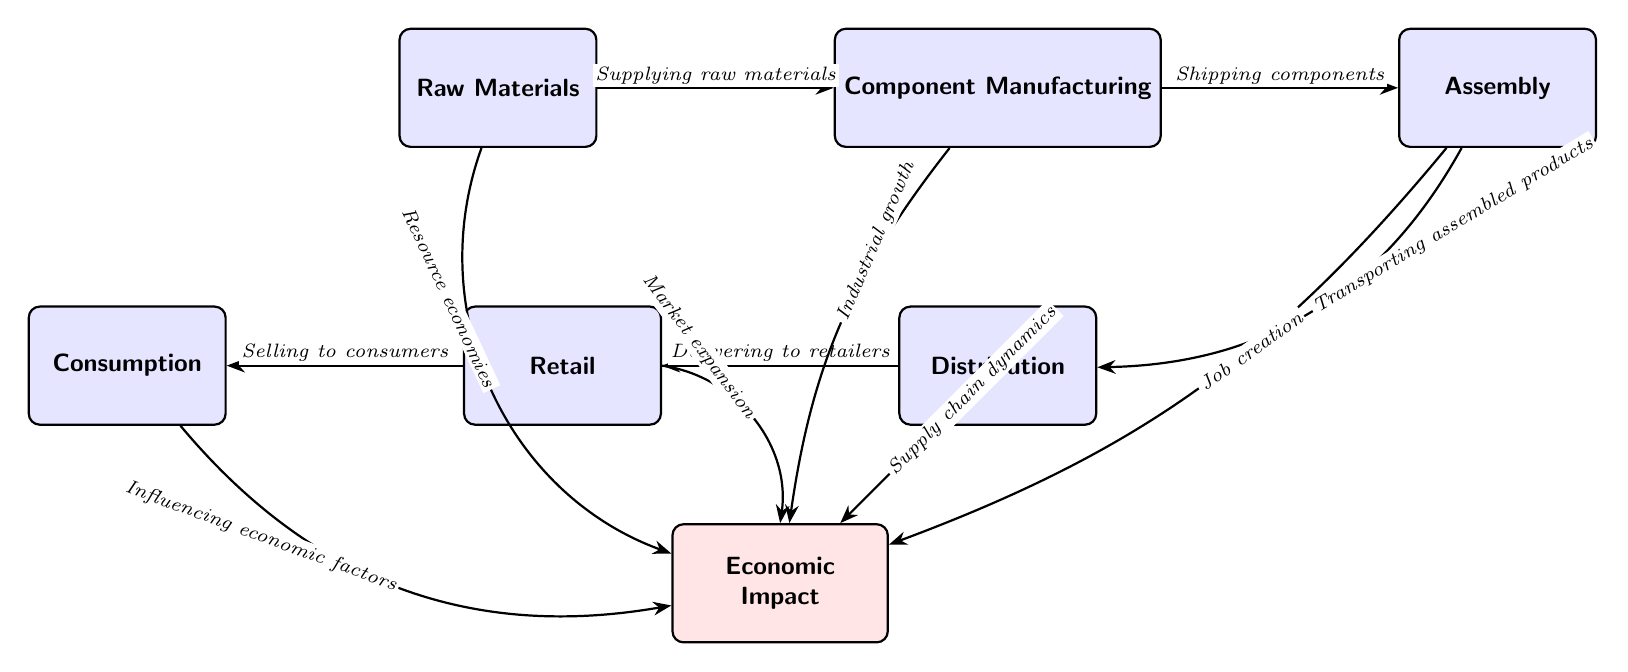What are the components in the global value chain? The components listed in the diagram are Raw Materials, Component Manufacturing, Assembly, Distribution, Retail, and Consumption.
Answer: Raw Materials, Component Manufacturing, Assembly, Distribution, Retail, Consumption How many nodes are there in the diagram? The diagram contains six main components (nodes) plus one impact node, which totals to seven nodes.
Answer: Seven What is the economic impact of component manufacturing? The impact connected to Component Manufacturing mentions "Industrial growth," indicating its economic contribution.
Answer: Industrial growth What does the assembly process contribute to the economic impact? The assembly process in the diagram relates to "Job creation," showing its positive effect on the economy.
Answer: Job creation Which node does the retail node connect to? The Retail node directly connects to the Consumption node, indicating the flow of products from retailers to consumers.
Answer: Consumption What influences economic factors in this diagram? Economic factors are influenced by the flow from the Consumption node, as shown in the diagram's arrows pointing towards the Economic Impact node.
Answer: Consumption What is the relationship between raw materials and economic impact? The diagram shows that raw materials have a connection labeled "Resource economies" that flows into the Economic Impact node, indicating their effect on the economy.
Answer: Resource economies How does distribution affect the economic impact? Distribution directly influences the economic impact via the arrow labeled "Supply chain dynamics," portraying its importance in the overall economic framework.
Answer: Supply chain dynamics Which component has a direct impact labeled "Market expansion"? The Retail component directly impacts the economy with the label "Market expansion," reflecting its role in enhancing market size.
Answer: Market expansion 